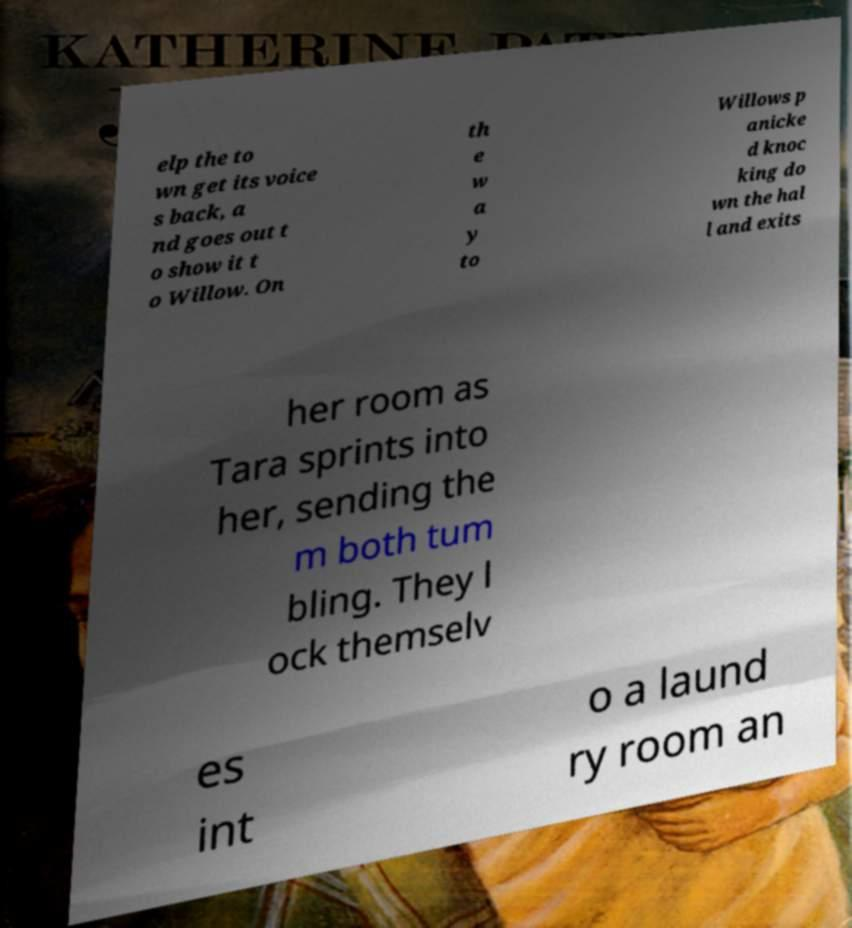Please identify and transcribe the text found in this image. elp the to wn get its voice s back, a nd goes out t o show it t o Willow. On th e w a y to Willows p anicke d knoc king do wn the hal l and exits her room as Tara sprints into her, sending the m both tum bling. They l ock themselv es int o a laund ry room an 